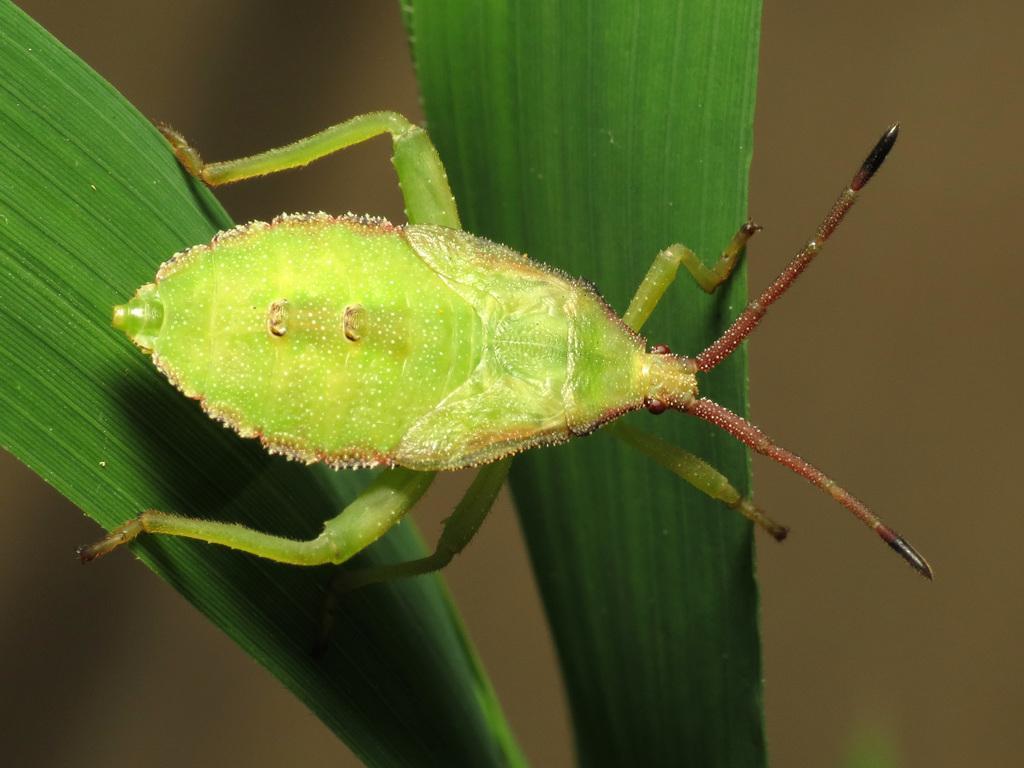Could you give a brief overview of what you see in this image? Here in this picture we can see a green colored bug present on the plant over there. 